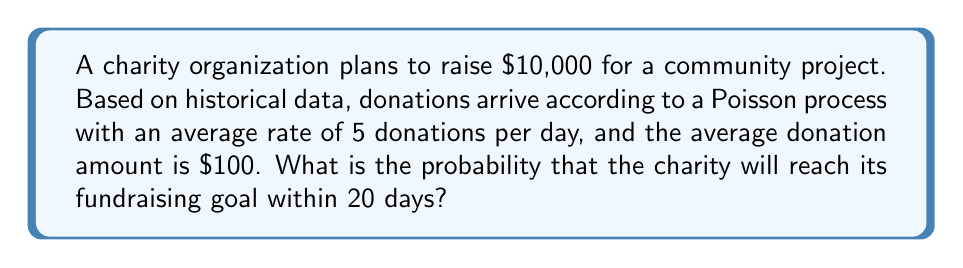Give your solution to this math problem. To solve this problem, we'll use the Poisson process and the Central Limit Theorem. Let's break it down step-by-step:

1) First, calculate the number of donations needed to reach the goal:
   $$\text{Number of donations needed} = \frac{\$10,000}{\$100} = 100$$

2) The average number of donations in 20 days:
   $$\lambda = 5 \text{ donations/day} \times 20 \text{ days} = 100$$

3) We need to find $P(X \geq 100)$, where $X$ is the number of donations in 20 days.

4) For large $\lambda$, the Poisson distribution can be approximated by a normal distribution:
   $$X \sim N(\lambda, \sqrt{\lambda})$$

5) Standardize the variable:
   $$Z = \frac{X - \lambda}{\sqrt{\lambda}} = \frac{X - 100}{10}$$

6) We want $P(X \geq 100)$, which is equivalent to $P(Z \geq 0)$

7) Using the standard normal distribution:
   $$P(Z \geq 0) = 1 - P(Z < 0) = 1 - 0.5 = 0.5$$

8) Therefore, the probability of reaching or exceeding the fundraising goal within 20 days is 0.5 or 50%.
Answer: 0.5 